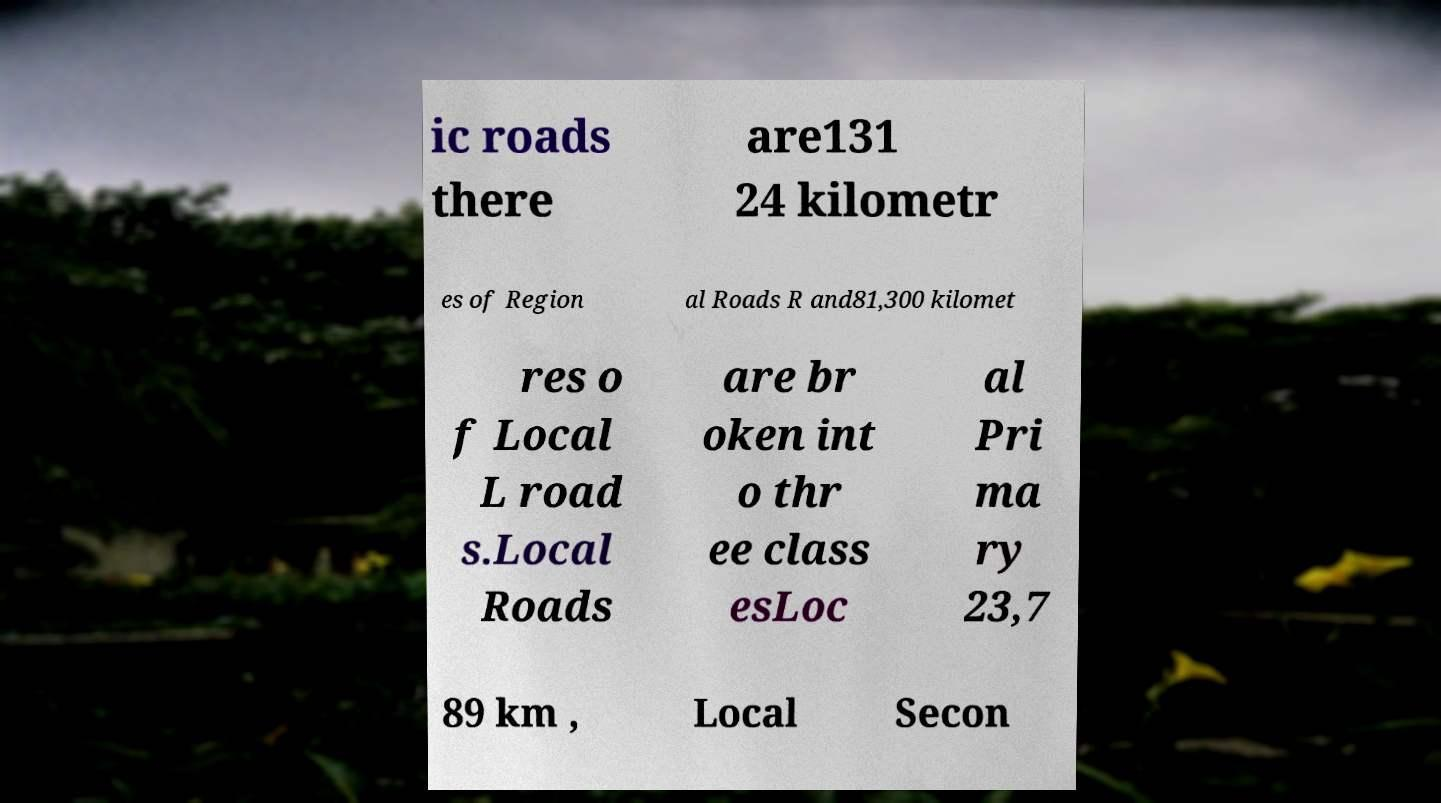Could you assist in decoding the text presented in this image and type it out clearly? ic roads there are131 24 kilometr es of Region al Roads R and81,300 kilomet res o f Local L road s.Local Roads are br oken int o thr ee class esLoc al Pri ma ry 23,7 89 km , Local Secon 